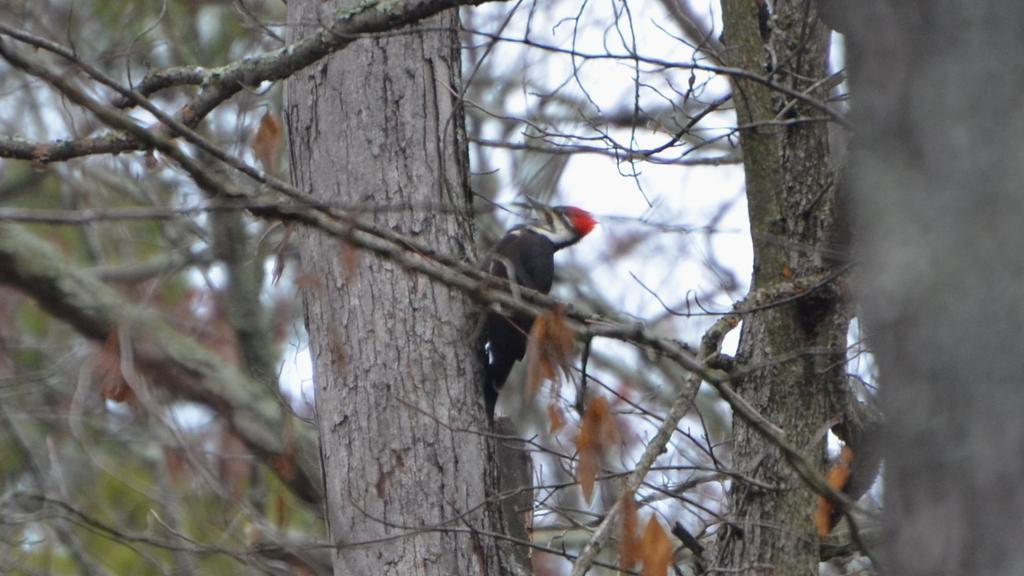What type of animal is in the image? There is a bird in the image. What colors can be seen on the bird? The bird has black, white, and red colors. Where is the bird located in the image? The bird is on a tree trunk. What is the color of the tree trunk? The tree trunk is ash in color. What can be seen in the background of the image? There are trees and the sky visible in the background of the image. What type of account does the bird have in the image? There is no mention of an account in the image; it features a bird on a tree trunk. Can you see a lake in the background of the image? There is no lake visible in the background of the image; it features trees and the sky. 